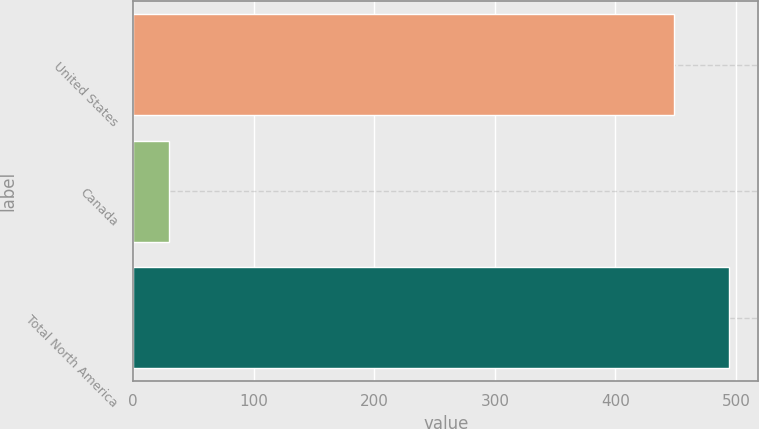<chart> <loc_0><loc_0><loc_500><loc_500><bar_chart><fcel>United States<fcel>Canada<fcel>Total North America<nl><fcel>449<fcel>30<fcel>493.9<nl></chart> 